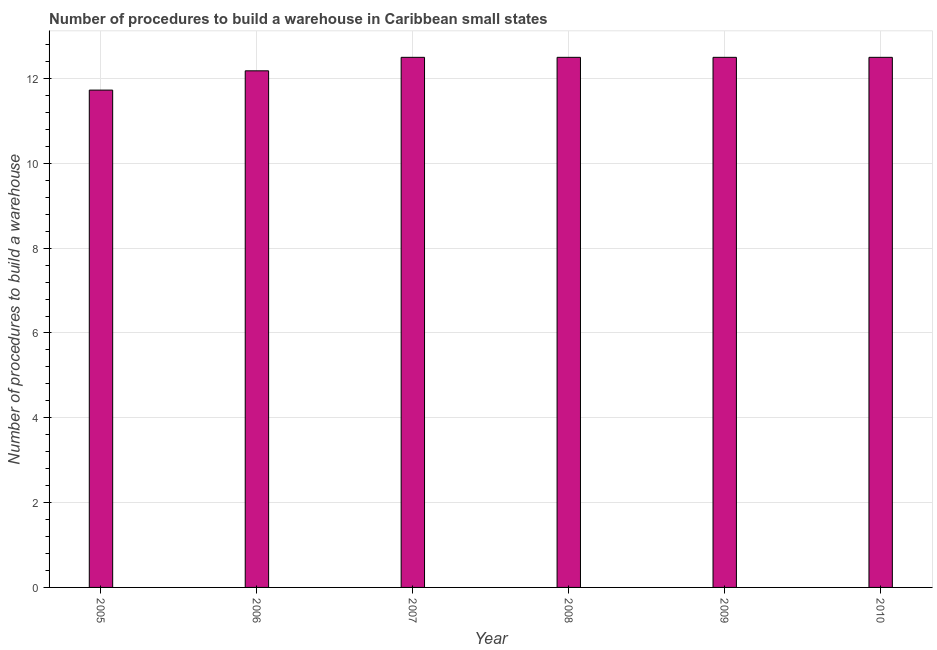Does the graph contain any zero values?
Offer a very short reply. No. What is the title of the graph?
Make the answer very short. Number of procedures to build a warehouse in Caribbean small states. What is the label or title of the Y-axis?
Provide a succinct answer. Number of procedures to build a warehouse. Across all years, what is the maximum number of procedures to build a warehouse?
Offer a very short reply. 12.5. Across all years, what is the minimum number of procedures to build a warehouse?
Provide a short and direct response. 11.73. In which year was the number of procedures to build a warehouse minimum?
Offer a very short reply. 2005. What is the sum of the number of procedures to build a warehouse?
Ensure brevity in your answer.  73.91. What is the difference between the number of procedures to build a warehouse in 2005 and 2006?
Ensure brevity in your answer.  -0.46. What is the average number of procedures to build a warehouse per year?
Offer a very short reply. 12.32. Do a majority of the years between 2006 and 2010 (inclusive) have number of procedures to build a warehouse greater than 0.4 ?
Your answer should be compact. Yes. Is the number of procedures to build a warehouse in 2005 less than that in 2010?
Keep it short and to the point. Yes. What is the difference between the highest and the lowest number of procedures to build a warehouse?
Your response must be concise. 0.77. In how many years, is the number of procedures to build a warehouse greater than the average number of procedures to build a warehouse taken over all years?
Your answer should be compact. 4. Are all the bars in the graph horizontal?
Keep it short and to the point. No. What is the difference between two consecutive major ticks on the Y-axis?
Offer a very short reply. 2. Are the values on the major ticks of Y-axis written in scientific E-notation?
Offer a very short reply. No. What is the Number of procedures to build a warehouse in 2005?
Keep it short and to the point. 11.73. What is the Number of procedures to build a warehouse in 2006?
Provide a succinct answer. 12.18. What is the Number of procedures to build a warehouse of 2007?
Your answer should be very brief. 12.5. What is the Number of procedures to build a warehouse of 2010?
Provide a succinct answer. 12.5. What is the difference between the Number of procedures to build a warehouse in 2005 and 2006?
Give a very brief answer. -0.45. What is the difference between the Number of procedures to build a warehouse in 2005 and 2007?
Offer a very short reply. -0.77. What is the difference between the Number of procedures to build a warehouse in 2005 and 2008?
Your answer should be very brief. -0.77. What is the difference between the Number of procedures to build a warehouse in 2005 and 2009?
Make the answer very short. -0.77. What is the difference between the Number of procedures to build a warehouse in 2005 and 2010?
Offer a very short reply. -0.77. What is the difference between the Number of procedures to build a warehouse in 2006 and 2007?
Give a very brief answer. -0.32. What is the difference between the Number of procedures to build a warehouse in 2006 and 2008?
Your answer should be compact. -0.32. What is the difference between the Number of procedures to build a warehouse in 2006 and 2009?
Give a very brief answer. -0.32. What is the difference between the Number of procedures to build a warehouse in 2006 and 2010?
Give a very brief answer. -0.32. What is the difference between the Number of procedures to build a warehouse in 2007 and 2008?
Ensure brevity in your answer.  0. What is the difference between the Number of procedures to build a warehouse in 2007 and 2009?
Provide a short and direct response. 0. What is the difference between the Number of procedures to build a warehouse in 2008 and 2010?
Offer a terse response. 0. What is the ratio of the Number of procedures to build a warehouse in 2005 to that in 2006?
Ensure brevity in your answer.  0.96. What is the ratio of the Number of procedures to build a warehouse in 2005 to that in 2007?
Provide a short and direct response. 0.94. What is the ratio of the Number of procedures to build a warehouse in 2005 to that in 2008?
Your response must be concise. 0.94. What is the ratio of the Number of procedures to build a warehouse in 2005 to that in 2009?
Your answer should be compact. 0.94. What is the ratio of the Number of procedures to build a warehouse in 2005 to that in 2010?
Give a very brief answer. 0.94. What is the ratio of the Number of procedures to build a warehouse in 2006 to that in 2007?
Provide a succinct answer. 0.97. What is the ratio of the Number of procedures to build a warehouse in 2006 to that in 2009?
Offer a terse response. 0.97. What is the ratio of the Number of procedures to build a warehouse in 2006 to that in 2010?
Offer a very short reply. 0.97. What is the ratio of the Number of procedures to build a warehouse in 2007 to that in 2010?
Provide a succinct answer. 1. What is the ratio of the Number of procedures to build a warehouse in 2008 to that in 2010?
Your response must be concise. 1. 